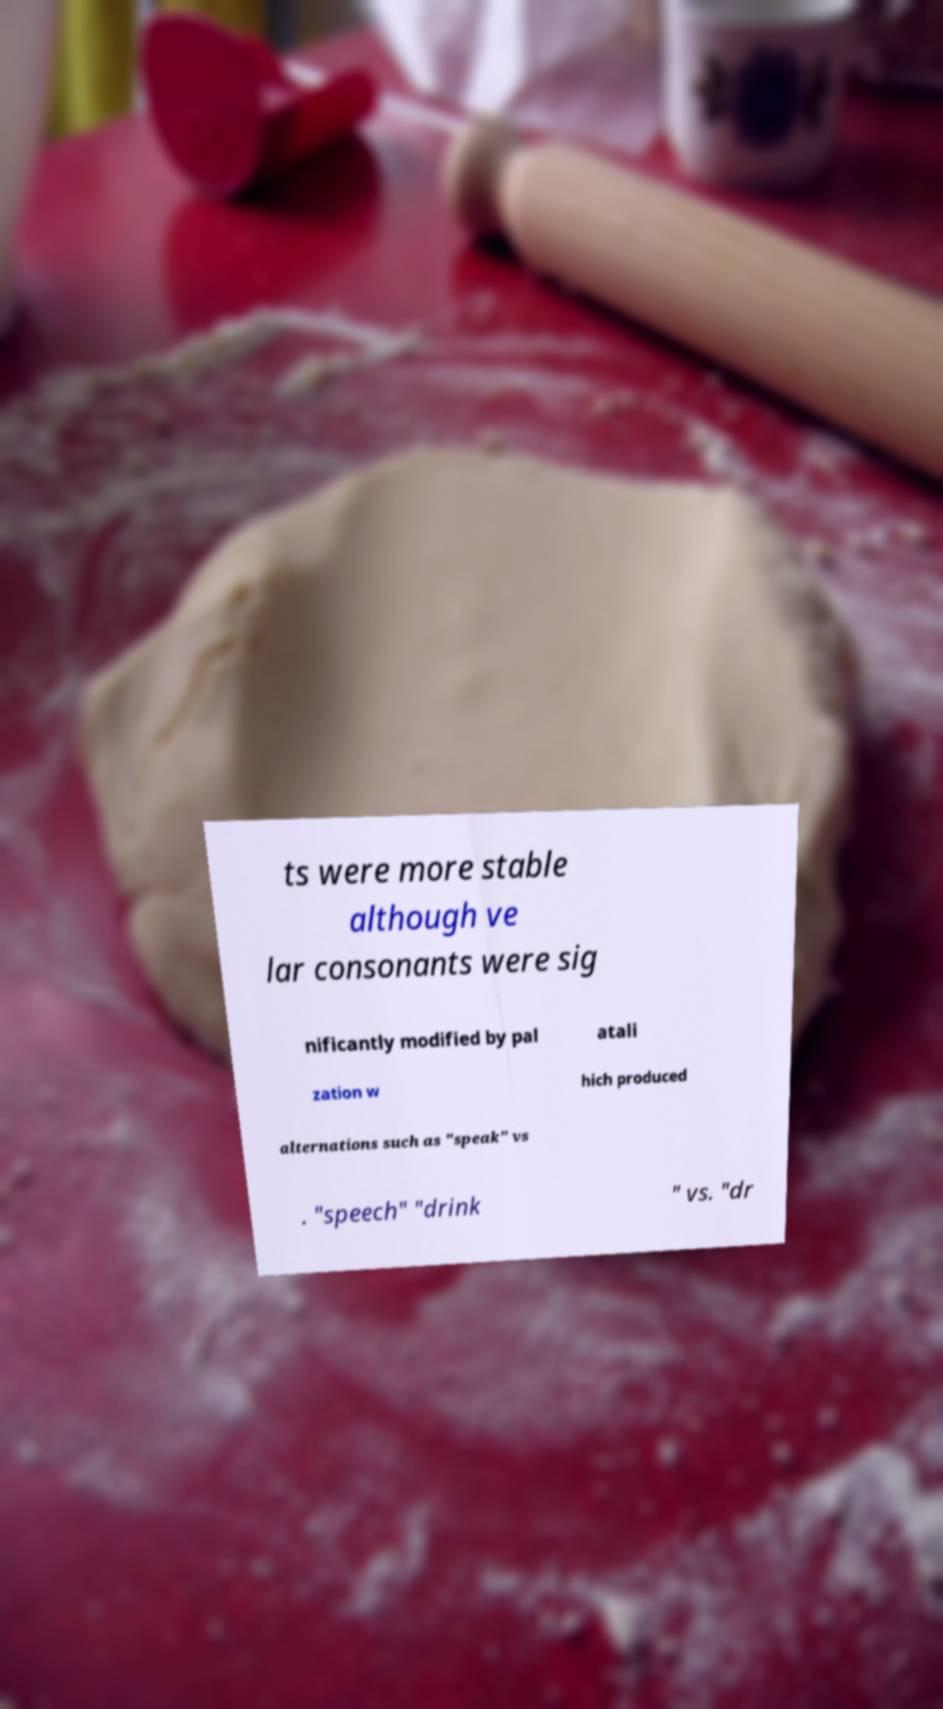Can you accurately transcribe the text from the provided image for me? ts were more stable although ve lar consonants were sig nificantly modified by pal atali zation w hich produced alternations such as "speak" vs . "speech" "drink " vs. "dr 